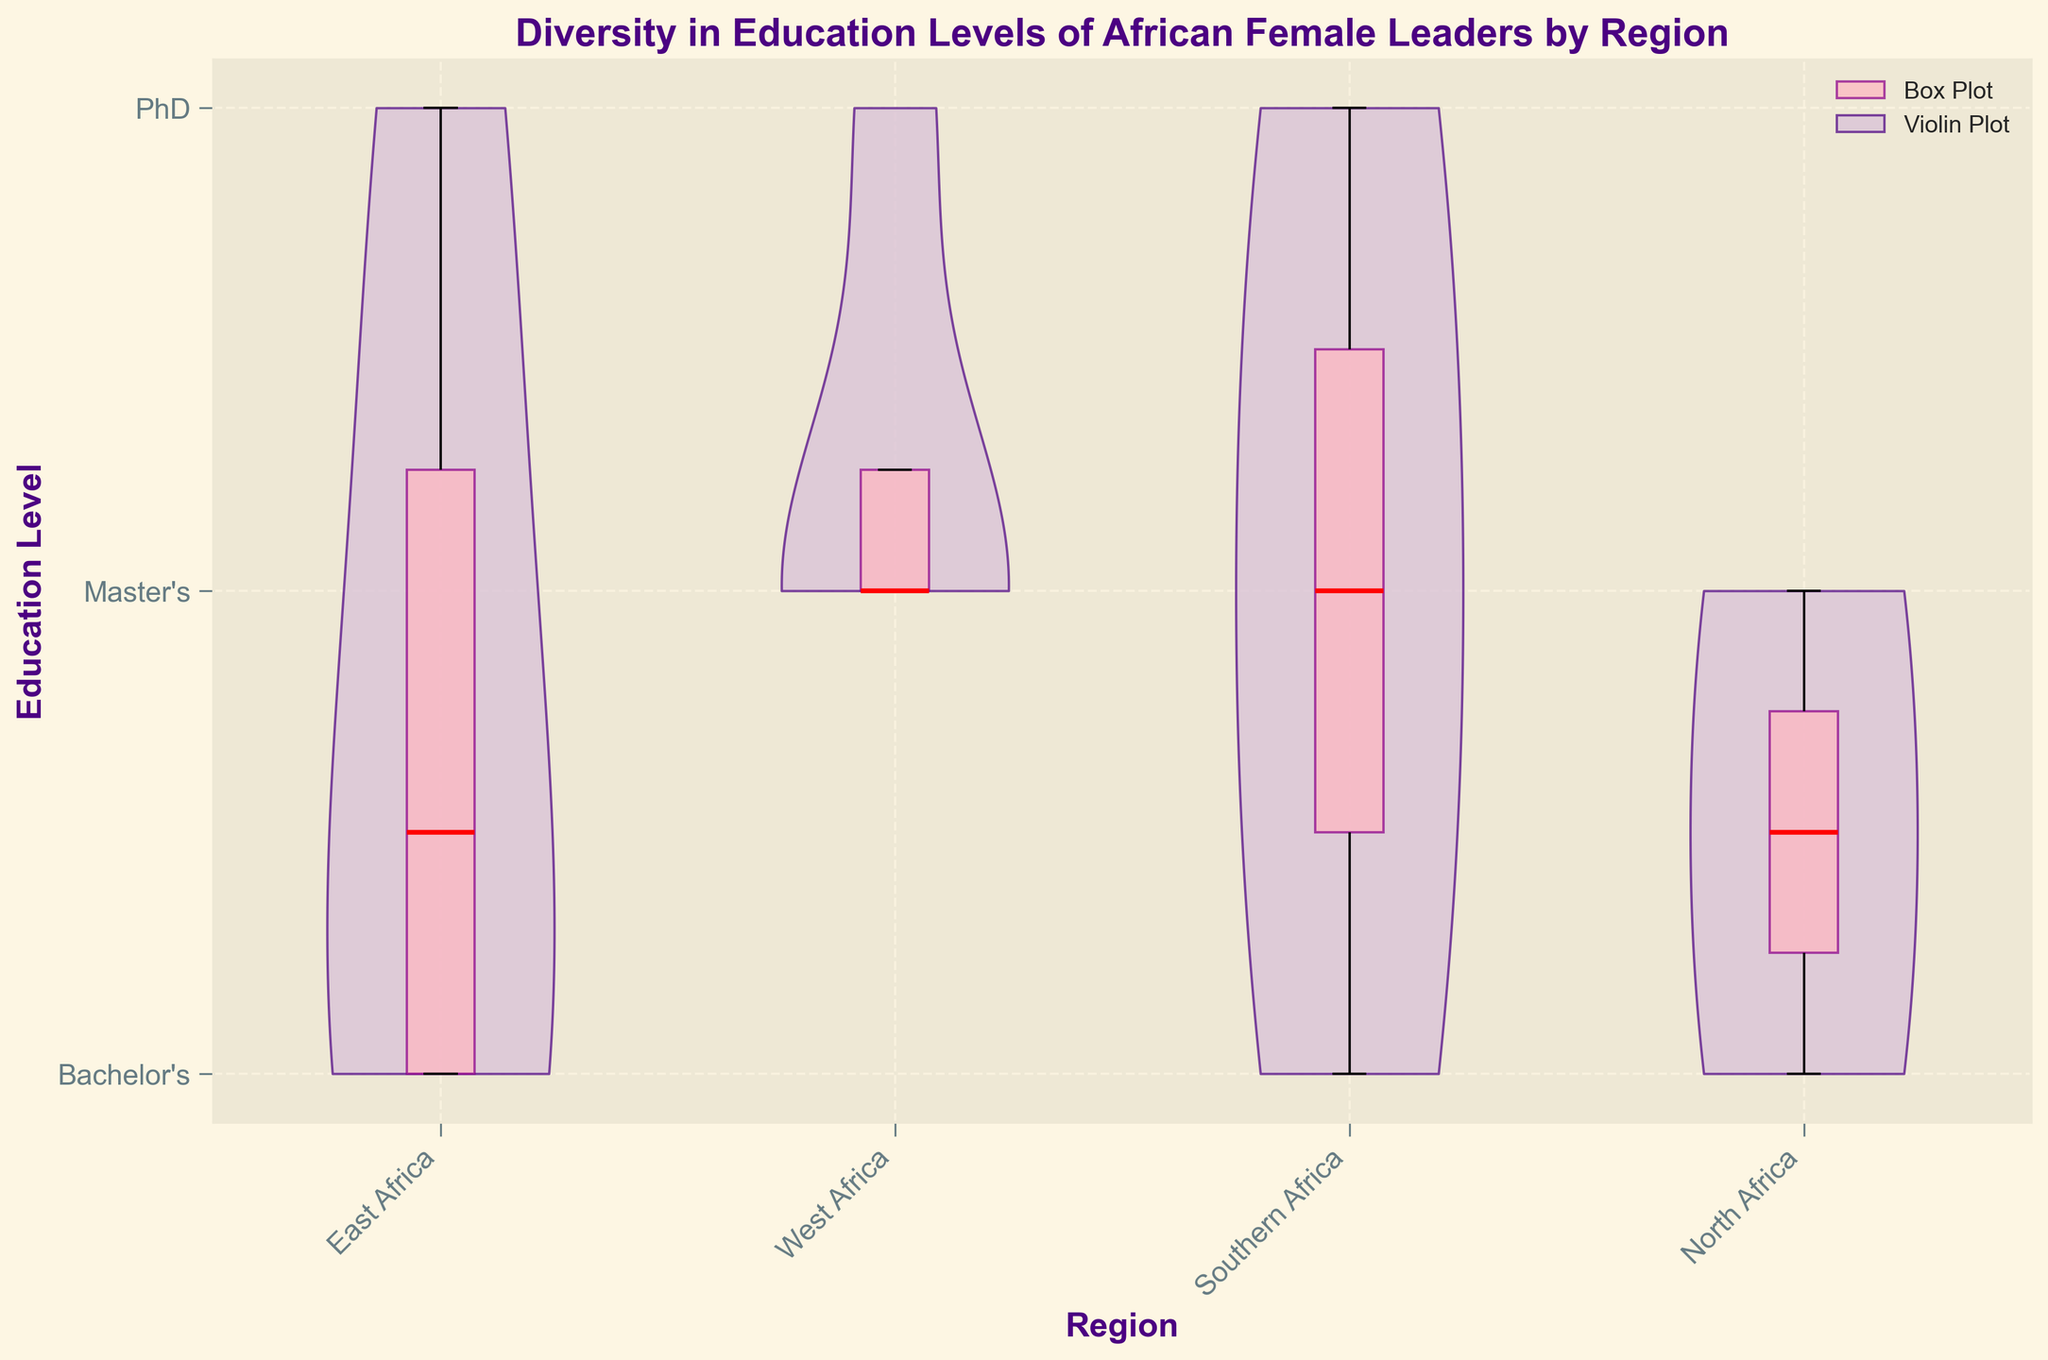what is the title of the plot? The title of the plot is often displayed at the top center of the figure. In this plot, the title reads, "Diversity in Education Levels of African Female Leaders by Region".
Answer: Diversity in Education Levels of African Female Leaders by Region What color is used for the body's face in the violin plots? The color used for the body's face in the violin plots is a light purple shade.
Answer: Light purple What are the regions represented on the x-axis of the plot? The x-axis of the plot lists the regions that are being analyzed. The regions are "East Africa," "West Africa," "Southern Africa," and "North Africa".
Answer: East Africa, West Africa, Southern Africa, North Africa Which education level corresponds to the highest y-axis value? The highest y-axis value on the plot corresponds to the education level of "PhD".
Answer: PhD What is the range of education levels displayed on the y-axis? The y-axis displays education levels starting from "Bachelor's" at the bottom, moving up to "Master's," and "PhD" at the top.
Answer: Bachelor's to PhD Which region shows the greatest spread of education levels? To determine the greatest spread, look at the width and spread of the violin plots for each region. "East Africa" has the widest spread, indicating the largest diversity in education levels.
Answer: East Africa In which region is the median education level the highest? Look at the red median lines on the box plots. "Southern Africa" has the highest median, represented by the red line at the "PhD" level.
Answer: Southern Africa How many regions have a median education level of Master's? Check the position of the red median lines on the box plots. Both "West Africa" and "North Africa" have median lines at the "Master's" level.
Answer: 2 regions What is the most common education level in East Africa? For the most common education level, look at where the violin plot is the widest. In East Africa, Bachelor's is the widest, indicating it is the most common.
Answer: Bachelor's Which education level is least represented in Southern Africa? For the least represented education level, look at where the violin plot is the narrowest. In Southern Africa, Bachelor's is the narrowest, indicating it is the least represented.
Answer: Bachelor's 